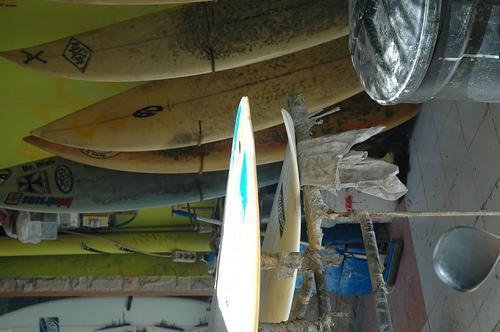How many surfboards are visible?
Give a very brief answer. 7. 